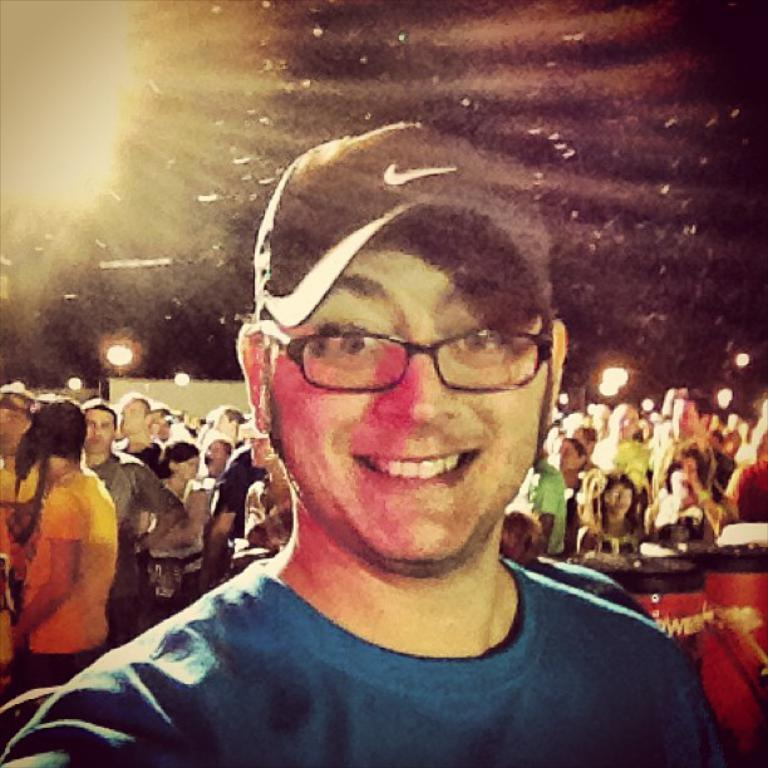Who is the main subject in the image? There is a man in the center of the image. What is the man doing in the image? The man is smiling. What can be seen in the background of the image? There is a crowd and lights visible in the background of the image. What musical instruments are present in the image? There are drums on the right side of the image. Can you see any deer or bun in the image? No, there are no deer or bun present in the image. Is there a bat flying in the background of the image? No, there is no bat visible in the image. 